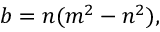<formula> <loc_0><loc_0><loc_500><loc_500>b = n ( m ^ { 2 } - n ^ { 2 } ) ,</formula> 